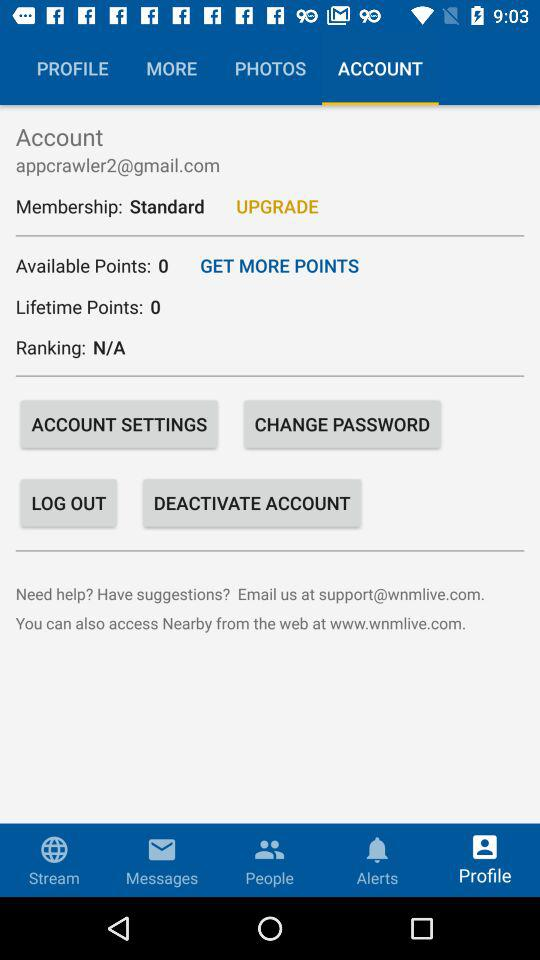What is the selected tab? The selected tab is "ACCOUNT". 